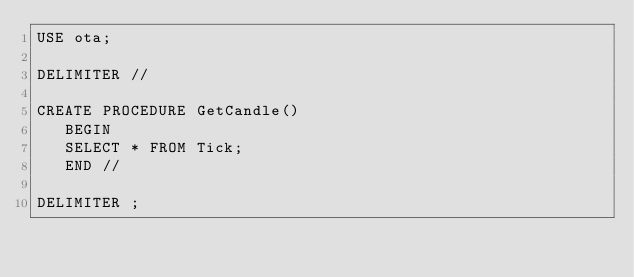<code> <loc_0><loc_0><loc_500><loc_500><_SQL_>USE ota;

DELIMITER //

CREATE PROCEDURE GetCandle()
   BEGIN
   SELECT * FROM Tick;
   END //

DELIMITER ;</code> 